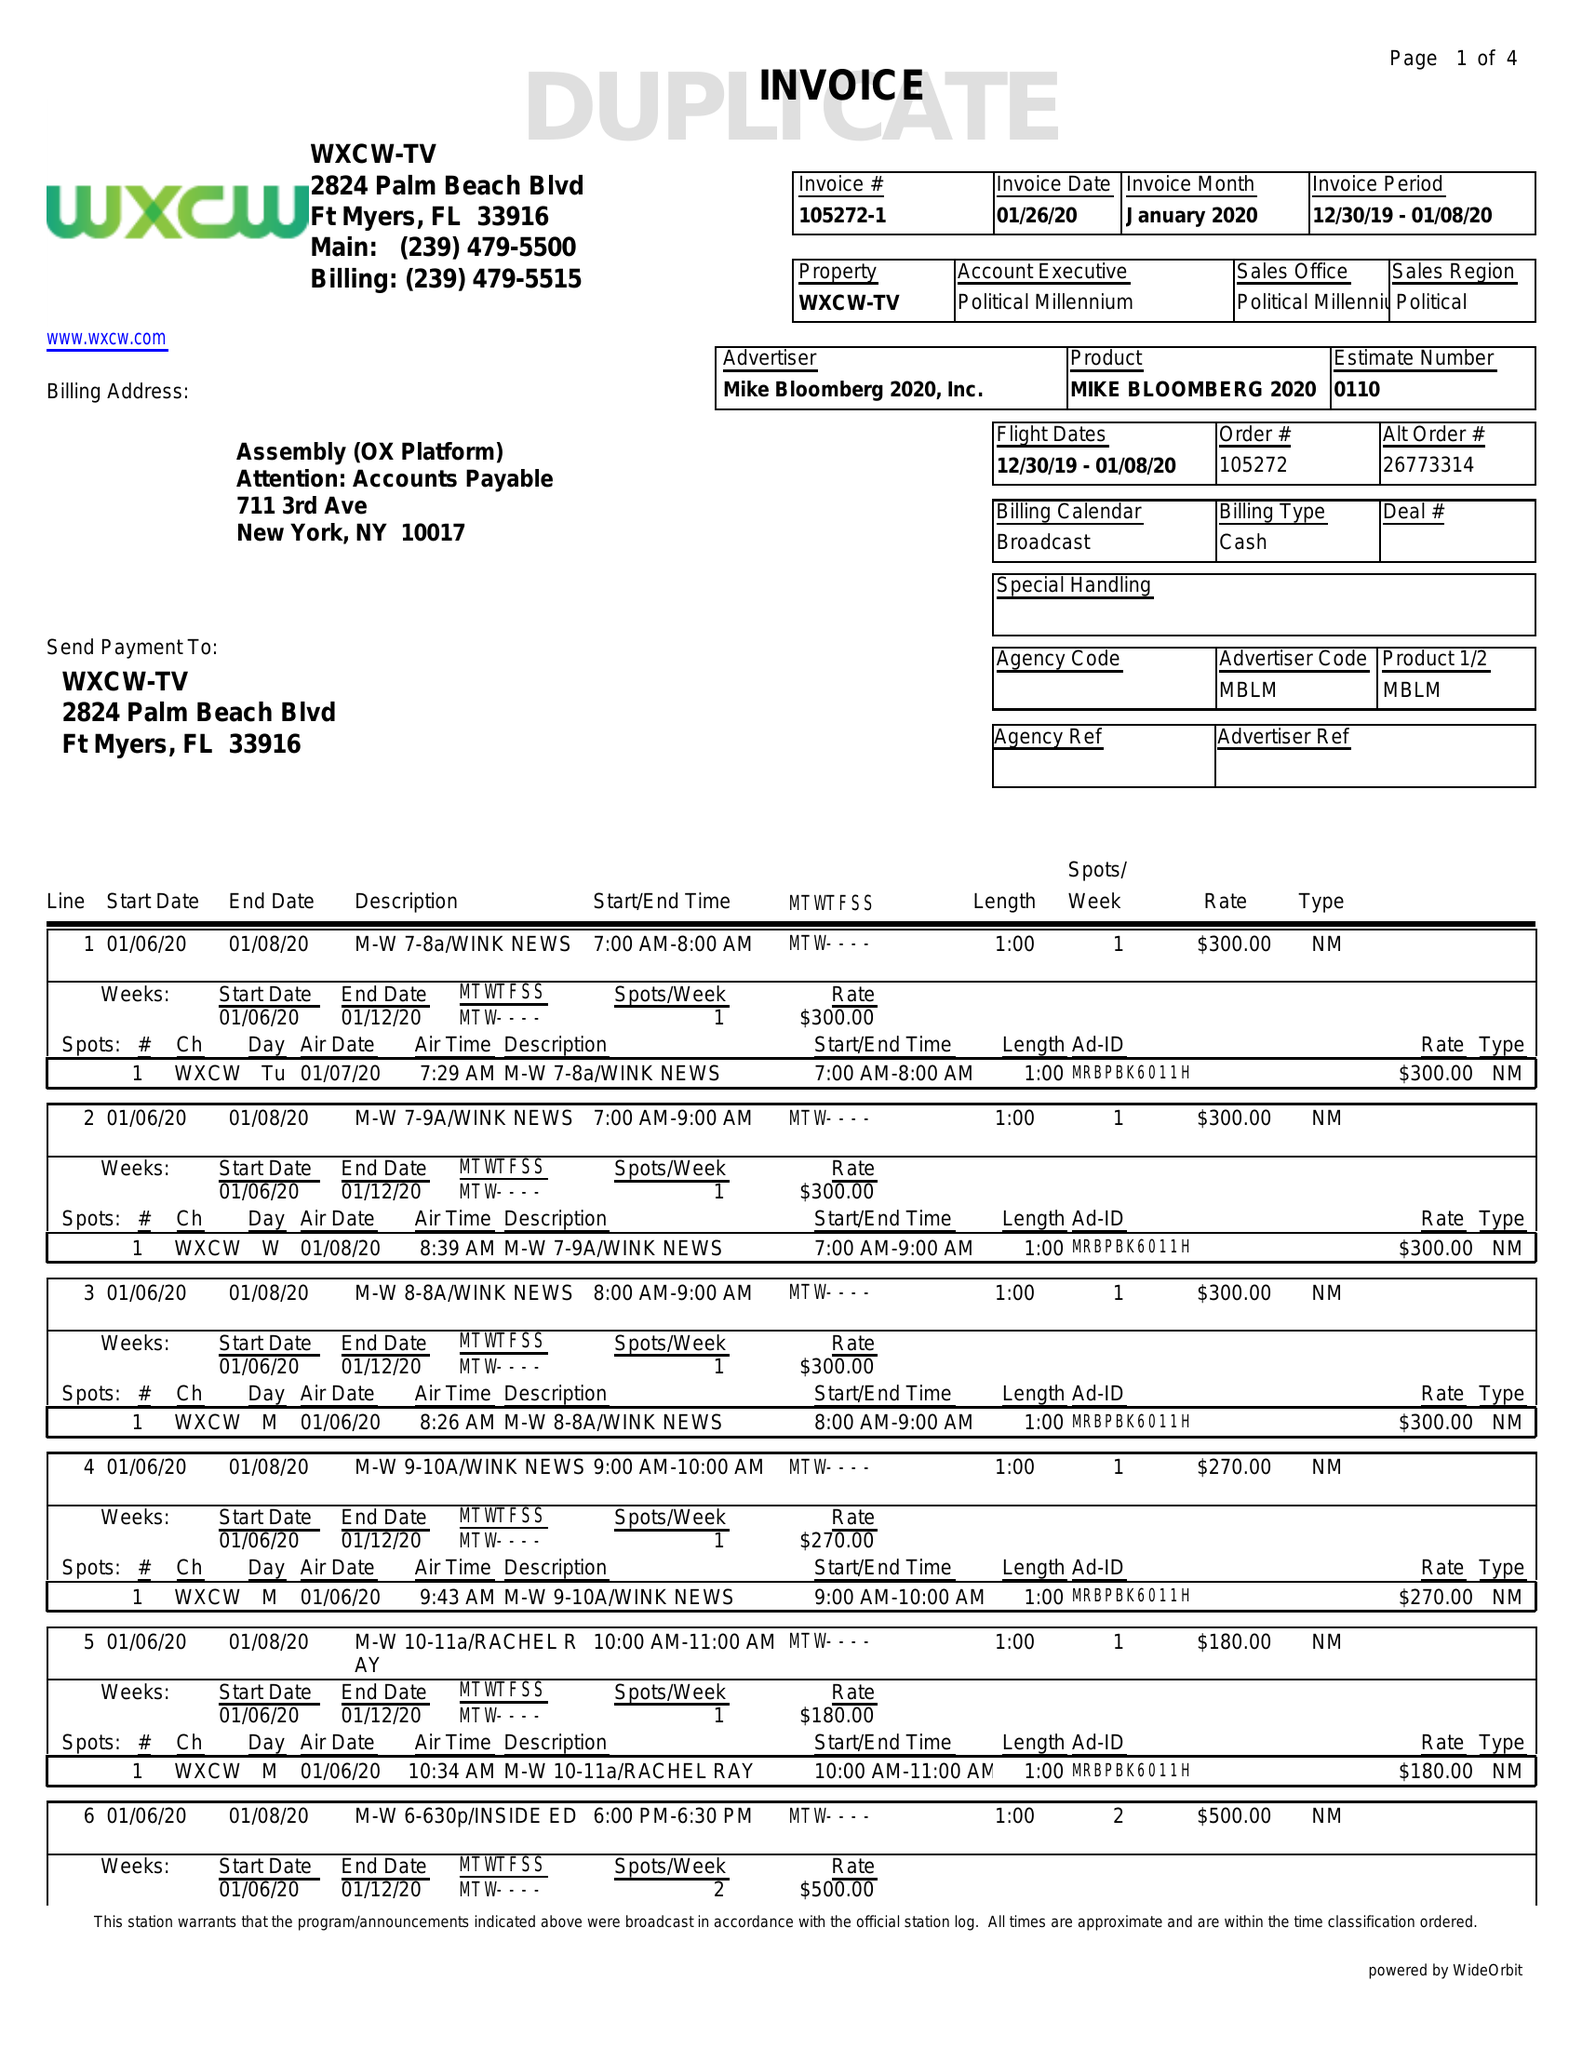What is the value for the flight_to?
Answer the question using a single word or phrase. 01/08/20 